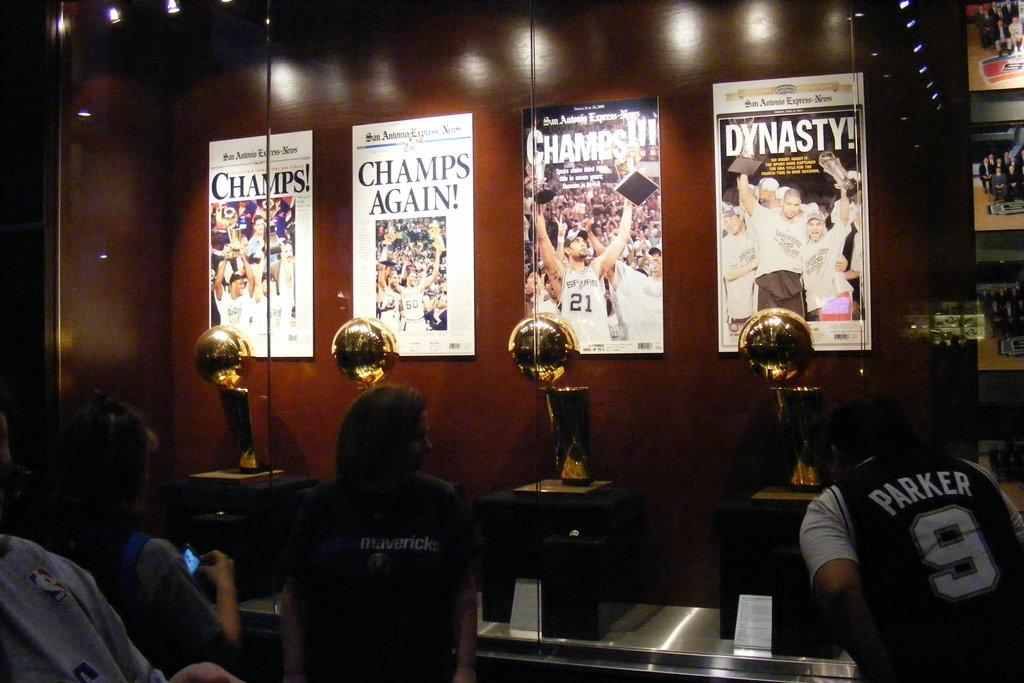<image>
Write a terse but informative summary of the picture. a jersey that has the number 9 on it 